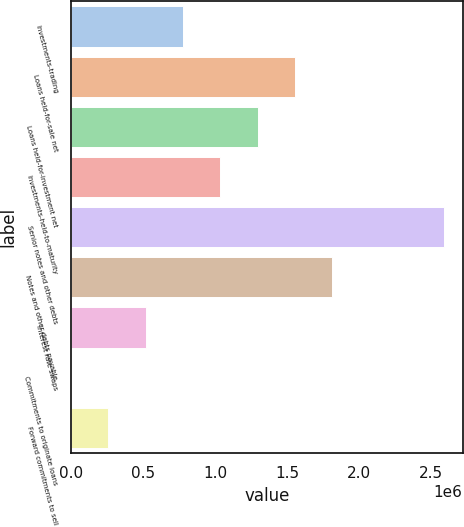Convert chart to OTSL. <chart><loc_0><loc_0><loc_500><loc_500><bar_chart><fcel>Investments-trading<fcel>Loans held-for-sale net<fcel>Loans held-for-investment net<fcel>Investments-held-to-maturity<fcel>Senior notes and other debts<fcel>Notes and other debts payable<fcel>Interest rate swaps<fcel>Commitments to originate loans<fcel>Forward commitments to sell<nl><fcel>777910<fcel>1.55571e+06<fcel>1.29644e+06<fcel>1.03718e+06<fcel>2.59277e+06<fcel>1.81497e+06<fcel>518644<fcel>112<fcel>259378<nl></chart> 